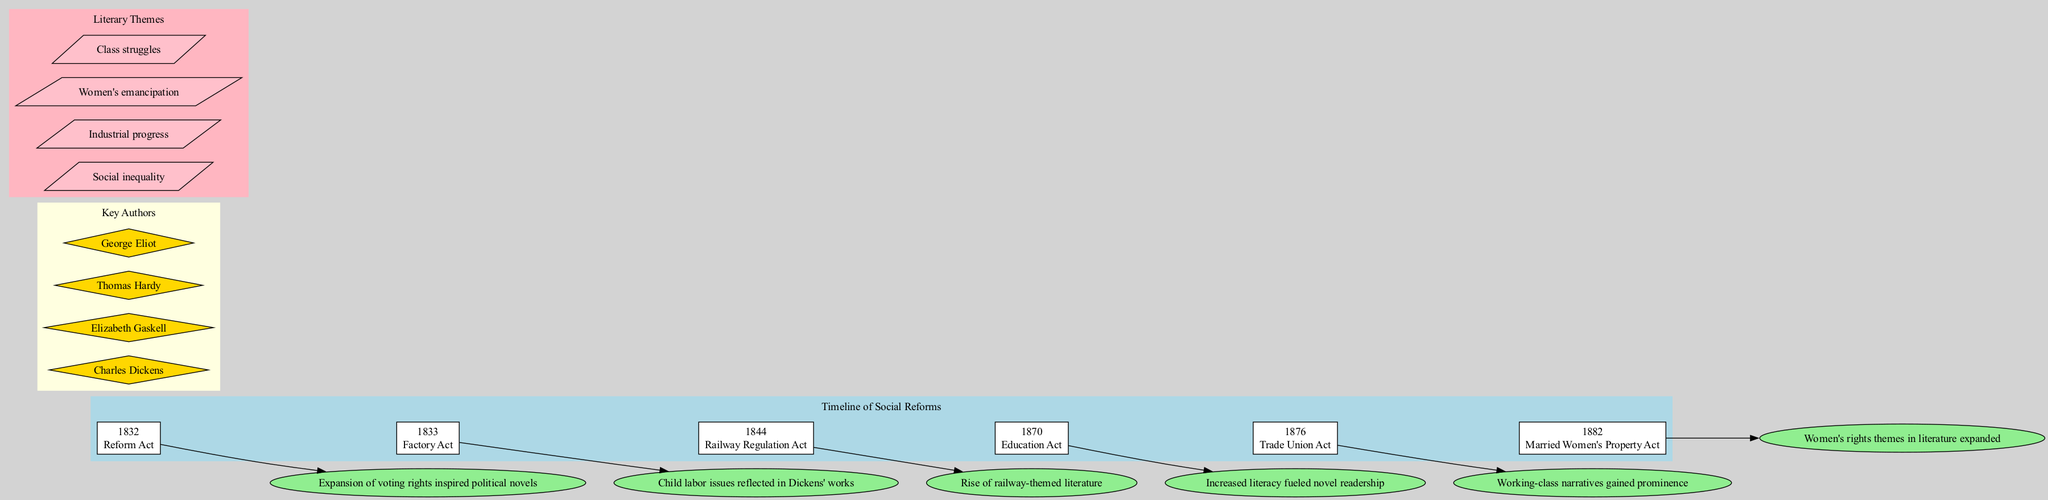What year did the Reform Act occur? The timeline specifies the year for the Reform Act as 1832. Therefore, by identifying the specific event denoted in the timeline section, we arrive at the answer.
Answer: 1832 Which reform was introduced in 1876? The timeline clearly lists the reform introduced in 1876 as the Trade Union Act. By looking at the specific year provided, we can find the reform associated with it.
Answer: Trade Union Act How many key authors are represented in the diagram? The section listing key authors contains four names: Charles Dickens, Elizabeth Gaskell, Thomas Hardy, and George Eliot. By counting these names, we determine the total number of authors.
Answer: 4 What is one impact of the Factory Act? The impact associated with the Factory Act is noted in the timeline as "Child labor issues reflected in Dickens' works." This direct reference from the timeline provides the necessary information.
Answer: Child labor issues reflected in Dickens' works Which literary theme relates to women's rights? The theme associated with women's rights in the literary themes section is "Women's emancipation." This is explicitly stated in the diagram, indicating that it addresses women's rights.
Answer: Women's emancipation What literary theme emerged due to the Education Act? The Education Act's impact led to increased literacy, which in turn fueled novel readership, connecting it to the theme of "Social inequality." Thus, analyzing the connections and influences reveals this theme.
Answer: Social inequality Which reform inspired political novels? The timeline suggests that the Reform Act in 1832 inspired political novels. Therefore, referencing this particular reform indicates the literature reaction to social changes at that time.
Answer: Reform Act Which year saw the introduction of the Married Women's Property Act? According to the timeline, the Married Women's Property Act was introduced in 1882. This can be determined by locating the specific reform under its corresponding year in the diagram.
Answer: 1882 